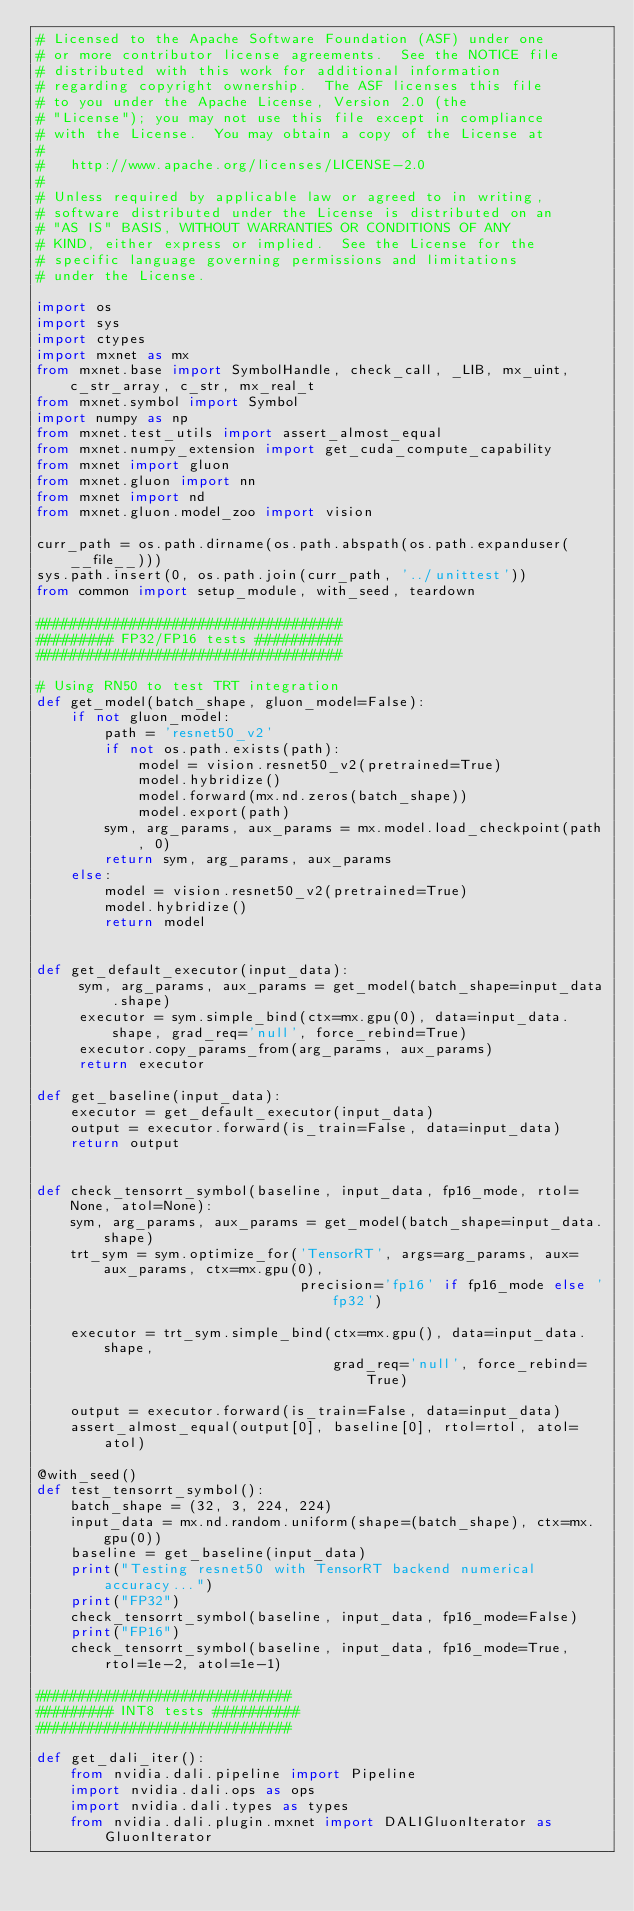Convert code to text. <code><loc_0><loc_0><loc_500><loc_500><_Python_># Licensed to the Apache Software Foundation (ASF) under one
# or more contributor license agreements.  See the NOTICE file
# distributed with this work for additional information
# regarding copyright ownership.  The ASF licenses this file
# to you under the Apache License, Version 2.0 (the
# "License"); you may not use this file except in compliance
# with the License.  You may obtain a copy of the License at
#
#   http://www.apache.org/licenses/LICENSE-2.0
#
# Unless required by applicable law or agreed to in writing,
# software distributed under the License is distributed on an
# "AS IS" BASIS, WITHOUT WARRANTIES OR CONDITIONS OF ANY
# KIND, either express or implied.  See the License for the
# specific language governing permissions and limitations
# under the License.

import os
import sys
import ctypes
import mxnet as mx
from mxnet.base import SymbolHandle, check_call, _LIB, mx_uint, c_str_array, c_str, mx_real_t
from mxnet.symbol import Symbol
import numpy as np
from mxnet.test_utils import assert_almost_equal
from mxnet.numpy_extension import get_cuda_compute_capability
from mxnet import gluon
from mxnet.gluon import nn
from mxnet import nd
from mxnet.gluon.model_zoo import vision

curr_path = os.path.dirname(os.path.abspath(os.path.expanduser(__file__)))
sys.path.insert(0, os.path.join(curr_path, '../unittest'))
from common import setup_module, with_seed, teardown

####################################
######### FP32/FP16 tests ##########
####################################

# Using RN50 to test TRT integration
def get_model(batch_shape, gluon_model=False):
    if not gluon_model:
        path = 'resnet50_v2'
        if not os.path.exists(path):
            model = vision.resnet50_v2(pretrained=True)
            model.hybridize()
            model.forward(mx.nd.zeros(batch_shape))
            model.export(path)
        sym, arg_params, aux_params = mx.model.load_checkpoint(path, 0)
        return sym, arg_params, aux_params
    else:
        model = vision.resnet50_v2(pretrained=True)
        model.hybridize()
        return model


def get_default_executor(input_data):
     sym, arg_params, aux_params = get_model(batch_shape=input_data.shape)
     executor = sym.simple_bind(ctx=mx.gpu(0), data=input_data.shape, grad_req='null', force_rebind=True)
     executor.copy_params_from(arg_params, aux_params)
     return executor    

def get_baseline(input_data):
    executor = get_default_executor(input_data) 
    output = executor.forward(is_train=False, data=input_data)
    return output


def check_tensorrt_symbol(baseline, input_data, fp16_mode, rtol=None, atol=None):
    sym, arg_params, aux_params = get_model(batch_shape=input_data.shape)
    trt_sym = sym.optimize_for('TensorRT', args=arg_params, aux=aux_params, ctx=mx.gpu(0),
                               precision='fp16' if fp16_mode else 'fp32')
    
    executor = trt_sym.simple_bind(ctx=mx.gpu(), data=input_data.shape,
                                   grad_req='null', force_rebind=True)

    output = executor.forward(is_train=False, data=input_data)
    assert_almost_equal(output[0], baseline[0], rtol=rtol, atol=atol)

@with_seed()
def test_tensorrt_symbol():
    batch_shape = (32, 3, 224, 224)
    input_data = mx.nd.random.uniform(shape=(batch_shape), ctx=mx.gpu(0))
    baseline = get_baseline(input_data)
    print("Testing resnet50 with TensorRT backend numerical accuracy...")
    print("FP32")
    check_tensorrt_symbol(baseline, input_data, fp16_mode=False)
    print("FP16")
    check_tensorrt_symbol(baseline, input_data, fp16_mode=True, rtol=1e-2, atol=1e-1)

##############################
######### INT8 tests ##########
##############################

def get_dali_iter():
    from nvidia.dali.pipeline import Pipeline
    import nvidia.dali.ops as ops
    import nvidia.dali.types as types
    from nvidia.dali.plugin.mxnet import DALIGluonIterator as GluonIterator
</code> 